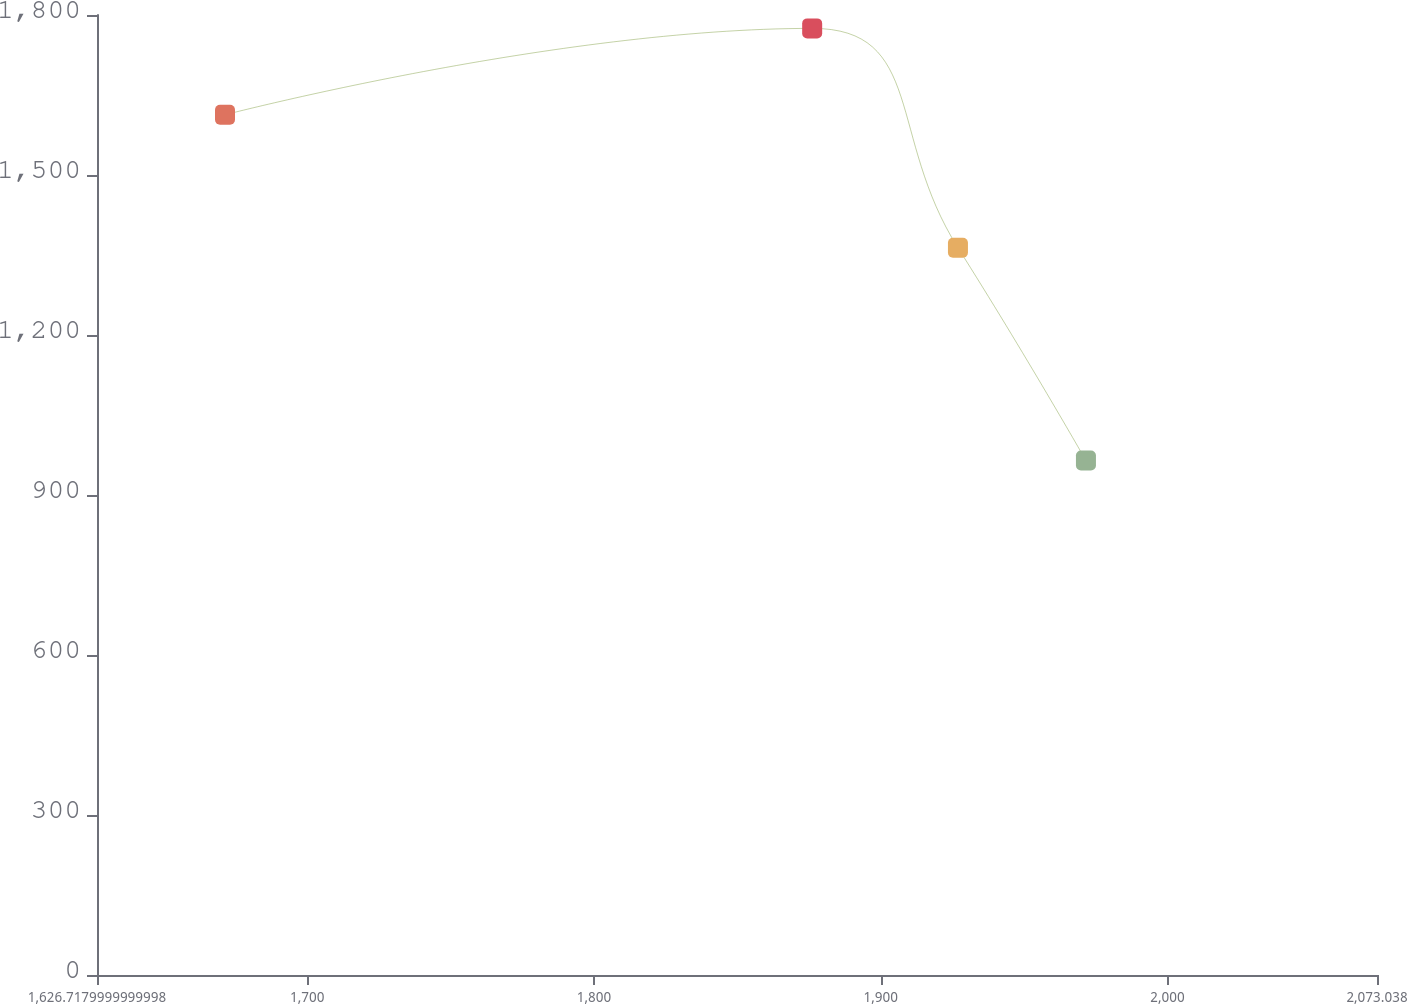Convert chart. <chart><loc_0><loc_0><loc_500><loc_500><line_chart><ecel><fcel>Unnamed: 1<nl><fcel>1671.35<fcel>1612.96<nl><fcel>1876.09<fcel>1774.91<nl><fcel>1926.92<fcel>1363.56<nl><fcel>1971.55<fcel>964.53<nl><fcel>2117.67<fcel>727.7<nl></chart> 